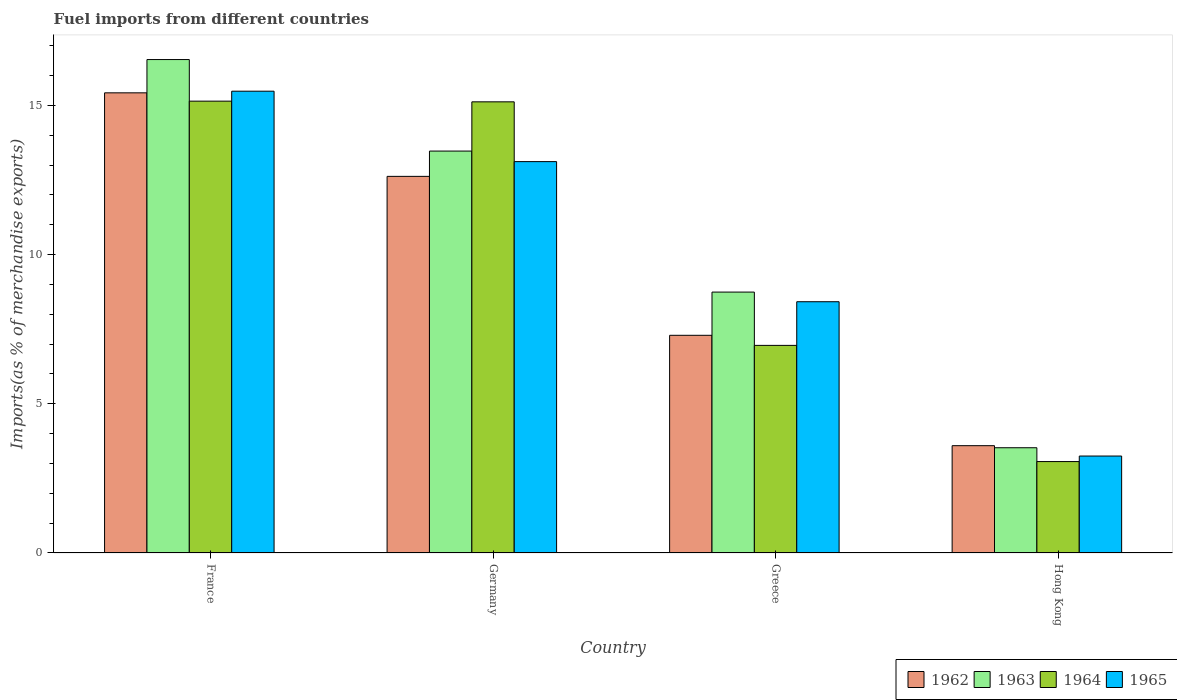How many groups of bars are there?
Offer a very short reply. 4. How many bars are there on the 2nd tick from the left?
Your answer should be compact. 4. How many bars are there on the 4th tick from the right?
Your answer should be very brief. 4. In how many cases, is the number of bars for a given country not equal to the number of legend labels?
Offer a terse response. 0. What is the percentage of imports to different countries in 1965 in Hong Kong?
Keep it short and to the point. 3.25. Across all countries, what is the maximum percentage of imports to different countries in 1962?
Give a very brief answer. 15.42. Across all countries, what is the minimum percentage of imports to different countries in 1962?
Keep it short and to the point. 3.6. In which country was the percentage of imports to different countries in 1962 minimum?
Keep it short and to the point. Hong Kong. What is the total percentage of imports to different countries in 1963 in the graph?
Make the answer very short. 42.28. What is the difference between the percentage of imports to different countries in 1965 in Germany and that in Greece?
Ensure brevity in your answer.  4.7. What is the difference between the percentage of imports to different countries in 1963 in France and the percentage of imports to different countries in 1964 in Hong Kong?
Provide a succinct answer. 13.47. What is the average percentage of imports to different countries in 1963 per country?
Your answer should be compact. 10.57. What is the difference between the percentage of imports to different countries of/in 1965 and percentage of imports to different countries of/in 1964 in France?
Your answer should be compact. 0.33. In how many countries, is the percentage of imports to different countries in 1962 greater than 4 %?
Keep it short and to the point. 3. What is the ratio of the percentage of imports to different countries in 1964 in Germany to that in Greece?
Provide a short and direct response. 2.17. Is the difference between the percentage of imports to different countries in 1965 in France and Hong Kong greater than the difference between the percentage of imports to different countries in 1964 in France and Hong Kong?
Your response must be concise. Yes. What is the difference between the highest and the second highest percentage of imports to different countries in 1962?
Make the answer very short. 5.33. What is the difference between the highest and the lowest percentage of imports to different countries in 1963?
Offer a very short reply. 13.01. Is it the case that in every country, the sum of the percentage of imports to different countries in 1963 and percentage of imports to different countries in 1962 is greater than the sum of percentage of imports to different countries in 1965 and percentage of imports to different countries in 1964?
Offer a terse response. No. What does the 4th bar from the left in Greece represents?
Provide a succinct answer. 1965. What does the 1st bar from the right in Greece represents?
Your response must be concise. 1965. Is it the case that in every country, the sum of the percentage of imports to different countries in 1963 and percentage of imports to different countries in 1962 is greater than the percentage of imports to different countries in 1965?
Your answer should be compact. Yes. What is the difference between two consecutive major ticks on the Y-axis?
Give a very brief answer. 5. Are the values on the major ticks of Y-axis written in scientific E-notation?
Provide a short and direct response. No. What is the title of the graph?
Give a very brief answer. Fuel imports from different countries. What is the label or title of the Y-axis?
Your answer should be compact. Imports(as % of merchandise exports). What is the Imports(as % of merchandise exports) in 1962 in France?
Keep it short and to the point. 15.42. What is the Imports(as % of merchandise exports) in 1963 in France?
Provide a short and direct response. 16.54. What is the Imports(as % of merchandise exports) in 1964 in France?
Provide a short and direct response. 15.14. What is the Imports(as % of merchandise exports) in 1965 in France?
Provide a succinct answer. 15.48. What is the Imports(as % of merchandise exports) of 1962 in Germany?
Offer a terse response. 12.62. What is the Imports(as % of merchandise exports) in 1963 in Germany?
Ensure brevity in your answer.  13.47. What is the Imports(as % of merchandise exports) of 1964 in Germany?
Provide a succinct answer. 15.12. What is the Imports(as % of merchandise exports) of 1965 in Germany?
Provide a succinct answer. 13.12. What is the Imports(as % of merchandise exports) in 1962 in Greece?
Provide a short and direct response. 7.3. What is the Imports(as % of merchandise exports) in 1963 in Greece?
Ensure brevity in your answer.  8.74. What is the Imports(as % of merchandise exports) in 1964 in Greece?
Make the answer very short. 6.96. What is the Imports(as % of merchandise exports) of 1965 in Greece?
Your answer should be very brief. 8.42. What is the Imports(as % of merchandise exports) of 1962 in Hong Kong?
Offer a very short reply. 3.6. What is the Imports(as % of merchandise exports) in 1963 in Hong Kong?
Give a very brief answer. 3.53. What is the Imports(as % of merchandise exports) in 1964 in Hong Kong?
Give a very brief answer. 3.06. What is the Imports(as % of merchandise exports) of 1965 in Hong Kong?
Provide a succinct answer. 3.25. Across all countries, what is the maximum Imports(as % of merchandise exports) of 1962?
Keep it short and to the point. 15.42. Across all countries, what is the maximum Imports(as % of merchandise exports) in 1963?
Your response must be concise. 16.54. Across all countries, what is the maximum Imports(as % of merchandise exports) of 1964?
Your response must be concise. 15.14. Across all countries, what is the maximum Imports(as % of merchandise exports) of 1965?
Ensure brevity in your answer.  15.48. Across all countries, what is the minimum Imports(as % of merchandise exports) in 1962?
Offer a very short reply. 3.6. Across all countries, what is the minimum Imports(as % of merchandise exports) in 1963?
Make the answer very short. 3.53. Across all countries, what is the minimum Imports(as % of merchandise exports) of 1964?
Your answer should be compact. 3.06. Across all countries, what is the minimum Imports(as % of merchandise exports) in 1965?
Your answer should be very brief. 3.25. What is the total Imports(as % of merchandise exports) in 1962 in the graph?
Keep it short and to the point. 38.94. What is the total Imports(as % of merchandise exports) in 1963 in the graph?
Ensure brevity in your answer.  42.28. What is the total Imports(as % of merchandise exports) of 1964 in the graph?
Ensure brevity in your answer.  40.29. What is the total Imports(as % of merchandise exports) of 1965 in the graph?
Offer a terse response. 40.26. What is the difference between the Imports(as % of merchandise exports) in 1962 in France and that in Germany?
Your response must be concise. 2.8. What is the difference between the Imports(as % of merchandise exports) of 1963 in France and that in Germany?
Keep it short and to the point. 3.07. What is the difference between the Imports(as % of merchandise exports) of 1964 in France and that in Germany?
Ensure brevity in your answer.  0.02. What is the difference between the Imports(as % of merchandise exports) in 1965 in France and that in Germany?
Offer a terse response. 2.36. What is the difference between the Imports(as % of merchandise exports) in 1962 in France and that in Greece?
Offer a very short reply. 8.13. What is the difference between the Imports(as % of merchandise exports) in 1963 in France and that in Greece?
Ensure brevity in your answer.  7.79. What is the difference between the Imports(as % of merchandise exports) in 1964 in France and that in Greece?
Provide a short and direct response. 8.19. What is the difference between the Imports(as % of merchandise exports) in 1965 in France and that in Greece?
Provide a succinct answer. 7.06. What is the difference between the Imports(as % of merchandise exports) of 1962 in France and that in Hong Kong?
Your answer should be very brief. 11.83. What is the difference between the Imports(as % of merchandise exports) in 1963 in France and that in Hong Kong?
Keep it short and to the point. 13.01. What is the difference between the Imports(as % of merchandise exports) of 1964 in France and that in Hong Kong?
Your response must be concise. 12.08. What is the difference between the Imports(as % of merchandise exports) of 1965 in France and that in Hong Kong?
Ensure brevity in your answer.  12.23. What is the difference between the Imports(as % of merchandise exports) of 1962 in Germany and that in Greece?
Ensure brevity in your answer.  5.33. What is the difference between the Imports(as % of merchandise exports) in 1963 in Germany and that in Greece?
Ensure brevity in your answer.  4.73. What is the difference between the Imports(as % of merchandise exports) in 1964 in Germany and that in Greece?
Your answer should be very brief. 8.16. What is the difference between the Imports(as % of merchandise exports) of 1965 in Germany and that in Greece?
Provide a short and direct response. 4.7. What is the difference between the Imports(as % of merchandise exports) of 1962 in Germany and that in Hong Kong?
Provide a short and direct response. 9.03. What is the difference between the Imports(as % of merchandise exports) of 1963 in Germany and that in Hong Kong?
Keep it short and to the point. 9.94. What is the difference between the Imports(as % of merchandise exports) of 1964 in Germany and that in Hong Kong?
Provide a short and direct response. 12.06. What is the difference between the Imports(as % of merchandise exports) in 1965 in Germany and that in Hong Kong?
Your answer should be very brief. 9.87. What is the difference between the Imports(as % of merchandise exports) in 1962 in Greece and that in Hong Kong?
Give a very brief answer. 3.7. What is the difference between the Imports(as % of merchandise exports) of 1963 in Greece and that in Hong Kong?
Provide a succinct answer. 5.22. What is the difference between the Imports(as % of merchandise exports) in 1964 in Greece and that in Hong Kong?
Your answer should be compact. 3.89. What is the difference between the Imports(as % of merchandise exports) in 1965 in Greece and that in Hong Kong?
Offer a very short reply. 5.17. What is the difference between the Imports(as % of merchandise exports) of 1962 in France and the Imports(as % of merchandise exports) of 1963 in Germany?
Offer a terse response. 1.95. What is the difference between the Imports(as % of merchandise exports) in 1962 in France and the Imports(as % of merchandise exports) in 1964 in Germany?
Your response must be concise. 0.3. What is the difference between the Imports(as % of merchandise exports) in 1962 in France and the Imports(as % of merchandise exports) in 1965 in Germany?
Offer a very short reply. 2.31. What is the difference between the Imports(as % of merchandise exports) in 1963 in France and the Imports(as % of merchandise exports) in 1964 in Germany?
Your answer should be compact. 1.42. What is the difference between the Imports(as % of merchandise exports) in 1963 in France and the Imports(as % of merchandise exports) in 1965 in Germany?
Provide a succinct answer. 3.42. What is the difference between the Imports(as % of merchandise exports) of 1964 in France and the Imports(as % of merchandise exports) of 1965 in Germany?
Make the answer very short. 2.03. What is the difference between the Imports(as % of merchandise exports) of 1962 in France and the Imports(as % of merchandise exports) of 1963 in Greece?
Make the answer very short. 6.68. What is the difference between the Imports(as % of merchandise exports) in 1962 in France and the Imports(as % of merchandise exports) in 1964 in Greece?
Offer a terse response. 8.46. What is the difference between the Imports(as % of merchandise exports) in 1962 in France and the Imports(as % of merchandise exports) in 1965 in Greece?
Your answer should be very brief. 7. What is the difference between the Imports(as % of merchandise exports) in 1963 in France and the Imports(as % of merchandise exports) in 1964 in Greece?
Provide a succinct answer. 9.58. What is the difference between the Imports(as % of merchandise exports) in 1963 in France and the Imports(as % of merchandise exports) in 1965 in Greece?
Your answer should be very brief. 8.12. What is the difference between the Imports(as % of merchandise exports) of 1964 in France and the Imports(as % of merchandise exports) of 1965 in Greece?
Make the answer very short. 6.72. What is the difference between the Imports(as % of merchandise exports) of 1962 in France and the Imports(as % of merchandise exports) of 1963 in Hong Kong?
Offer a terse response. 11.89. What is the difference between the Imports(as % of merchandise exports) in 1962 in France and the Imports(as % of merchandise exports) in 1964 in Hong Kong?
Make the answer very short. 12.36. What is the difference between the Imports(as % of merchandise exports) in 1962 in France and the Imports(as % of merchandise exports) in 1965 in Hong Kong?
Ensure brevity in your answer.  12.17. What is the difference between the Imports(as % of merchandise exports) of 1963 in France and the Imports(as % of merchandise exports) of 1964 in Hong Kong?
Offer a terse response. 13.47. What is the difference between the Imports(as % of merchandise exports) in 1963 in France and the Imports(as % of merchandise exports) in 1965 in Hong Kong?
Give a very brief answer. 13.29. What is the difference between the Imports(as % of merchandise exports) in 1964 in France and the Imports(as % of merchandise exports) in 1965 in Hong Kong?
Make the answer very short. 11.89. What is the difference between the Imports(as % of merchandise exports) in 1962 in Germany and the Imports(as % of merchandise exports) in 1963 in Greece?
Your response must be concise. 3.88. What is the difference between the Imports(as % of merchandise exports) of 1962 in Germany and the Imports(as % of merchandise exports) of 1964 in Greece?
Give a very brief answer. 5.66. What is the difference between the Imports(as % of merchandise exports) in 1962 in Germany and the Imports(as % of merchandise exports) in 1965 in Greece?
Ensure brevity in your answer.  4.2. What is the difference between the Imports(as % of merchandise exports) in 1963 in Germany and the Imports(as % of merchandise exports) in 1964 in Greece?
Offer a very short reply. 6.51. What is the difference between the Imports(as % of merchandise exports) in 1963 in Germany and the Imports(as % of merchandise exports) in 1965 in Greece?
Offer a very short reply. 5.05. What is the difference between the Imports(as % of merchandise exports) of 1964 in Germany and the Imports(as % of merchandise exports) of 1965 in Greece?
Offer a terse response. 6.7. What is the difference between the Imports(as % of merchandise exports) of 1962 in Germany and the Imports(as % of merchandise exports) of 1963 in Hong Kong?
Make the answer very short. 9.1. What is the difference between the Imports(as % of merchandise exports) in 1962 in Germany and the Imports(as % of merchandise exports) in 1964 in Hong Kong?
Your response must be concise. 9.56. What is the difference between the Imports(as % of merchandise exports) in 1962 in Germany and the Imports(as % of merchandise exports) in 1965 in Hong Kong?
Your answer should be compact. 9.37. What is the difference between the Imports(as % of merchandise exports) in 1963 in Germany and the Imports(as % of merchandise exports) in 1964 in Hong Kong?
Offer a terse response. 10.41. What is the difference between the Imports(as % of merchandise exports) of 1963 in Germany and the Imports(as % of merchandise exports) of 1965 in Hong Kong?
Offer a very short reply. 10.22. What is the difference between the Imports(as % of merchandise exports) in 1964 in Germany and the Imports(as % of merchandise exports) in 1965 in Hong Kong?
Give a very brief answer. 11.87. What is the difference between the Imports(as % of merchandise exports) in 1962 in Greece and the Imports(as % of merchandise exports) in 1963 in Hong Kong?
Provide a succinct answer. 3.77. What is the difference between the Imports(as % of merchandise exports) of 1962 in Greece and the Imports(as % of merchandise exports) of 1964 in Hong Kong?
Ensure brevity in your answer.  4.23. What is the difference between the Imports(as % of merchandise exports) of 1962 in Greece and the Imports(as % of merchandise exports) of 1965 in Hong Kong?
Make the answer very short. 4.05. What is the difference between the Imports(as % of merchandise exports) in 1963 in Greece and the Imports(as % of merchandise exports) in 1964 in Hong Kong?
Offer a very short reply. 5.68. What is the difference between the Imports(as % of merchandise exports) in 1963 in Greece and the Imports(as % of merchandise exports) in 1965 in Hong Kong?
Make the answer very short. 5.49. What is the difference between the Imports(as % of merchandise exports) in 1964 in Greece and the Imports(as % of merchandise exports) in 1965 in Hong Kong?
Your answer should be compact. 3.71. What is the average Imports(as % of merchandise exports) of 1962 per country?
Provide a short and direct response. 9.73. What is the average Imports(as % of merchandise exports) in 1963 per country?
Keep it short and to the point. 10.57. What is the average Imports(as % of merchandise exports) in 1964 per country?
Provide a short and direct response. 10.07. What is the average Imports(as % of merchandise exports) in 1965 per country?
Keep it short and to the point. 10.07. What is the difference between the Imports(as % of merchandise exports) in 1962 and Imports(as % of merchandise exports) in 1963 in France?
Your answer should be very brief. -1.12. What is the difference between the Imports(as % of merchandise exports) in 1962 and Imports(as % of merchandise exports) in 1964 in France?
Your response must be concise. 0.28. What is the difference between the Imports(as % of merchandise exports) of 1962 and Imports(as % of merchandise exports) of 1965 in France?
Your answer should be very brief. -0.05. What is the difference between the Imports(as % of merchandise exports) in 1963 and Imports(as % of merchandise exports) in 1964 in France?
Offer a terse response. 1.39. What is the difference between the Imports(as % of merchandise exports) in 1963 and Imports(as % of merchandise exports) in 1965 in France?
Give a very brief answer. 1.06. What is the difference between the Imports(as % of merchandise exports) in 1964 and Imports(as % of merchandise exports) in 1965 in France?
Your response must be concise. -0.33. What is the difference between the Imports(as % of merchandise exports) of 1962 and Imports(as % of merchandise exports) of 1963 in Germany?
Make the answer very short. -0.85. What is the difference between the Imports(as % of merchandise exports) in 1962 and Imports(as % of merchandise exports) in 1964 in Germany?
Your answer should be compact. -2.5. What is the difference between the Imports(as % of merchandise exports) in 1962 and Imports(as % of merchandise exports) in 1965 in Germany?
Make the answer very short. -0.49. What is the difference between the Imports(as % of merchandise exports) of 1963 and Imports(as % of merchandise exports) of 1964 in Germany?
Offer a terse response. -1.65. What is the difference between the Imports(as % of merchandise exports) in 1963 and Imports(as % of merchandise exports) in 1965 in Germany?
Give a very brief answer. 0.35. What is the difference between the Imports(as % of merchandise exports) in 1964 and Imports(as % of merchandise exports) in 1965 in Germany?
Provide a succinct answer. 2. What is the difference between the Imports(as % of merchandise exports) in 1962 and Imports(as % of merchandise exports) in 1963 in Greece?
Your response must be concise. -1.45. What is the difference between the Imports(as % of merchandise exports) of 1962 and Imports(as % of merchandise exports) of 1964 in Greece?
Provide a short and direct response. 0.34. What is the difference between the Imports(as % of merchandise exports) in 1962 and Imports(as % of merchandise exports) in 1965 in Greece?
Keep it short and to the point. -1.13. What is the difference between the Imports(as % of merchandise exports) of 1963 and Imports(as % of merchandise exports) of 1964 in Greece?
Ensure brevity in your answer.  1.79. What is the difference between the Imports(as % of merchandise exports) of 1963 and Imports(as % of merchandise exports) of 1965 in Greece?
Your answer should be compact. 0.32. What is the difference between the Imports(as % of merchandise exports) of 1964 and Imports(as % of merchandise exports) of 1965 in Greece?
Offer a very short reply. -1.46. What is the difference between the Imports(as % of merchandise exports) in 1962 and Imports(as % of merchandise exports) in 1963 in Hong Kong?
Offer a very short reply. 0.07. What is the difference between the Imports(as % of merchandise exports) in 1962 and Imports(as % of merchandise exports) in 1964 in Hong Kong?
Your answer should be compact. 0.53. What is the difference between the Imports(as % of merchandise exports) in 1962 and Imports(as % of merchandise exports) in 1965 in Hong Kong?
Keep it short and to the point. 0.35. What is the difference between the Imports(as % of merchandise exports) in 1963 and Imports(as % of merchandise exports) in 1964 in Hong Kong?
Your response must be concise. 0.46. What is the difference between the Imports(as % of merchandise exports) in 1963 and Imports(as % of merchandise exports) in 1965 in Hong Kong?
Keep it short and to the point. 0.28. What is the difference between the Imports(as % of merchandise exports) of 1964 and Imports(as % of merchandise exports) of 1965 in Hong Kong?
Provide a short and direct response. -0.19. What is the ratio of the Imports(as % of merchandise exports) of 1962 in France to that in Germany?
Provide a succinct answer. 1.22. What is the ratio of the Imports(as % of merchandise exports) of 1963 in France to that in Germany?
Your answer should be very brief. 1.23. What is the ratio of the Imports(as % of merchandise exports) in 1965 in France to that in Germany?
Provide a short and direct response. 1.18. What is the ratio of the Imports(as % of merchandise exports) in 1962 in France to that in Greece?
Your answer should be very brief. 2.11. What is the ratio of the Imports(as % of merchandise exports) of 1963 in France to that in Greece?
Your answer should be very brief. 1.89. What is the ratio of the Imports(as % of merchandise exports) of 1964 in France to that in Greece?
Offer a terse response. 2.18. What is the ratio of the Imports(as % of merchandise exports) of 1965 in France to that in Greece?
Provide a short and direct response. 1.84. What is the ratio of the Imports(as % of merchandise exports) of 1962 in France to that in Hong Kong?
Give a very brief answer. 4.29. What is the ratio of the Imports(as % of merchandise exports) in 1963 in France to that in Hong Kong?
Provide a short and direct response. 4.69. What is the ratio of the Imports(as % of merchandise exports) in 1964 in France to that in Hong Kong?
Provide a succinct answer. 4.94. What is the ratio of the Imports(as % of merchandise exports) of 1965 in France to that in Hong Kong?
Offer a very short reply. 4.76. What is the ratio of the Imports(as % of merchandise exports) of 1962 in Germany to that in Greece?
Ensure brevity in your answer.  1.73. What is the ratio of the Imports(as % of merchandise exports) in 1963 in Germany to that in Greece?
Offer a very short reply. 1.54. What is the ratio of the Imports(as % of merchandise exports) of 1964 in Germany to that in Greece?
Offer a very short reply. 2.17. What is the ratio of the Imports(as % of merchandise exports) in 1965 in Germany to that in Greece?
Give a very brief answer. 1.56. What is the ratio of the Imports(as % of merchandise exports) of 1962 in Germany to that in Hong Kong?
Keep it short and to the point. 3.51. What is the ratio of the Imports(as % of merchandise exports) of 1963 in Germany to that in Hong Kong?
Provide a short and direct response. 3.82. What is the ratio of the Imports(as % of merchandise exports) of 1964 in Germany to that in Hong Kong?
Offer a very short reply. 4.94. What is the ratio of the Imports(as % of merchandise exports) in 1965 in Germany to that in Hong Kong?
Keep it short and to the point. 4.04. What is the ratio of the Imports(as % of merchandise exports) in 1962 in Greece to that in Hong Kong?
Give a very brief answer. 2.03. What is the ratio of the Imports(as % of merchandise exports) of 1963 in Greece to that in Hong Kong?
Make the answer very short. 2.48. What is the ratio of the Imports(as % of merchandise exports) of 1964 in Greece to that in Hong Kong?
Ensure brevity in your answer.  2.27. What is the ratio of the Imports(as % of merchandise exports) in 1965 in Greece to that in Hong Kong?
Give a very brief answer. 2.59. What is the difference between the highest and the second highest Imports(as % of merchandise exports) of 1962?
Make the answer very short. 2.8. What is the difference between the highest and the second highest Imports(as % of merchandise exports) of 1963?
Provide a short and direct response. 3.07. What is the difference between the highest and the second highest Imports(as % of merchandise exports) of 1964?
Your answer should be compact. 0.02. What is the difference between the highest and the second highest Imports(as % of merchandise exports) in 1965?
Give a very brief answer. 2.36. What is the difference between the highest and the lowest Imports(as % of merchandise exports) of 1962?
Provide a succinct answer. 11.83. What is the difference between the highest and the lowest Imports(as % of merchandise exports) of 1963?
Keep it short and to the point. 13.01. What is the difference between the highest and the lowest Imports(as % of merchandise exports) of 1964?
Your response must be concise. 12.08. What is the difference between the highest and the lowest Imports(as % of merchandise exports) in 1965?
Make the answer very short. 12.23. 